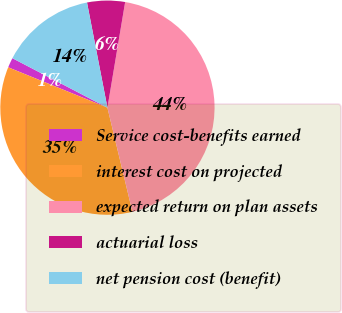Convert chart to OTSL. <chart><loc_0><loc_0><loc_500><loc_500><pie_chart><fcel>Service cost-benefits earned<fcel>interest cost on projected<fcel>expected return on plan assets<fcel>actuarial loss<fcel>net pension cost (benefit)<nl><fcel>1.49%<fcel>34.9%<fcel>43.61%<fcel>5.7%<fcel>14.31%<nl></chart> 